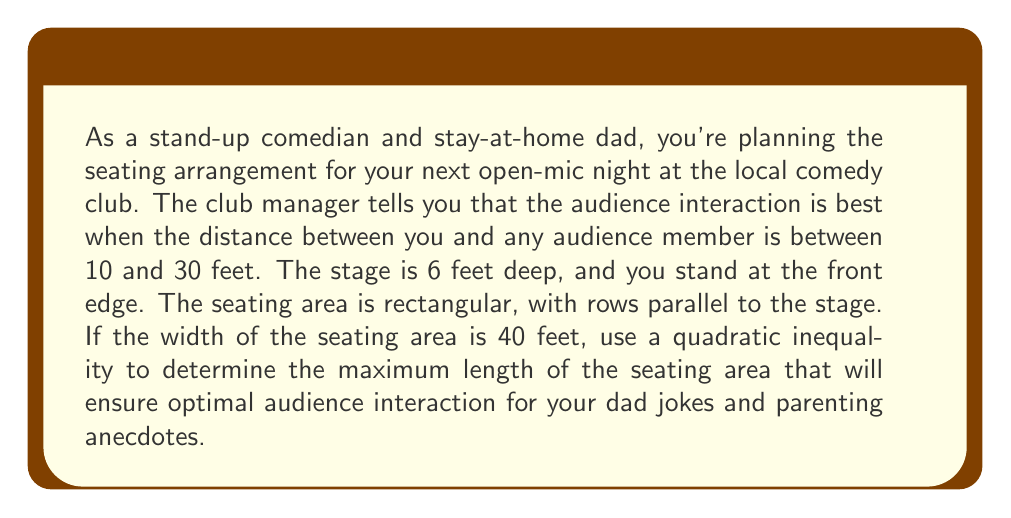Could you help me with this problem? Let's approach this step-by-step:

1) Let $x$ be the length of the seating area in feet.

2) The farthest audience member will be at the back corner of the seating area. We can use the Pythagorean theorem to express this distance:

   $$\text{distance}^2 = x^2 + 20^2$$

   (We use 20 feet as half the width since the farthest point will be at a corner)

3) We want this distance to be at most 30 feet:

   $$x^2 + 20^2 \leq 30^2$$

4) We also need to consider the closest audience member. They will be seated right in front of the stage. This distance should be at least 10 feet:

   $$x \geq 10$$

5) Solving the quadratic inequality:

   $$x^2 + 20^2 \leq 30^2$$
   $$x^2 + 400 \leq 900$$
   $$x^2 \leq 500$$
   $$x \leq \sqrt{500} \approx 22.36$$

6) Combining this with our other inequality:

   $$10 \leq x \leq 22.36$$

7) Since we're looking for the maximum length, we want the upper bound of this inequality.
Answer: The maximum length of the seating area should be approximately 22.36 feet. For practical purposes, this could be rounded down to 22 feet to ensure all seats are within the optimal interaction range. 